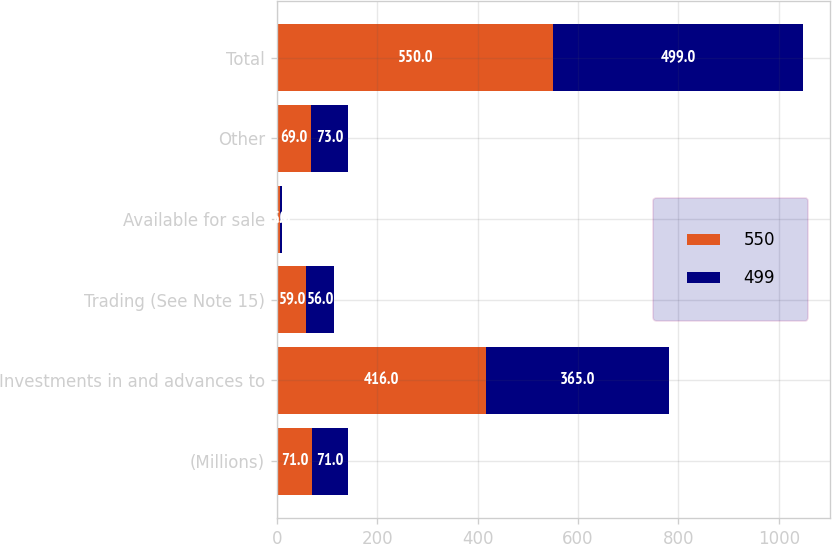<chart> <loc_0><loc_0><loc_500><loc_500><stacked_bar_chart><ecel><fcel>(Millions)<fcel>Investments in and advances to<fcel>Trading (See Note 15)<fcel>Available for sale<fcel>Other<fcel>Total<nl><fcel>550<fcel>71<fcel>416<fcel>59<fcel>6<fcel>69<fcel>550<nl><fcel>499<fcel>71<fcel>365<fcel>56<fcel>5<fcel>73<fcel>499<nl></chart> 